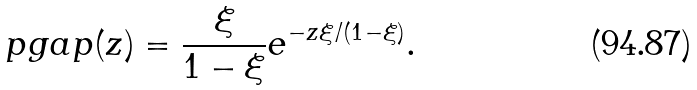Convert formula to latex. <formula><loc_0><loc_0><loc_500><loc_500>\ p g a p ( z ) = \frac { \xi } { 1 - \xi } e ^ { - z \xi / ( 1 - \xi ) } .</formula> 